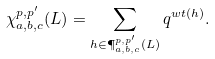Convert formula to latex. <formula><loc_0><loc_0><loc_500><loc_500>\chi ^ { p , p ^ { \prime } } _ { a , b , c } ( L ) = \sum _ { h \in { \P } ^ { p , p ^ { \prime } } _ { a , b , c } ( L ) } q ^ { w t ( h ) } .</formula> 